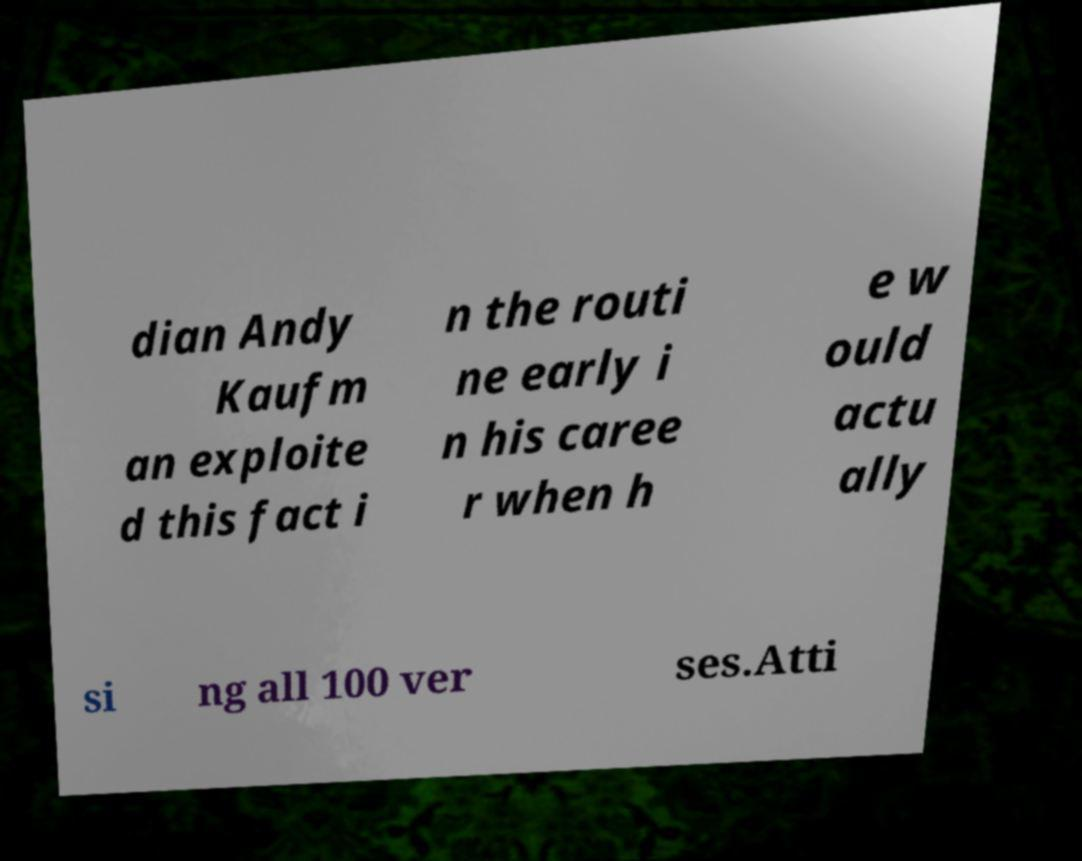I need the written content from this picture converted into text. Can you do that? dian Andy Kaufm an exploite d this fact i n the routi ne early i n his caree r when h e w ould actu ally si ng all 100 ver ses.Atti 